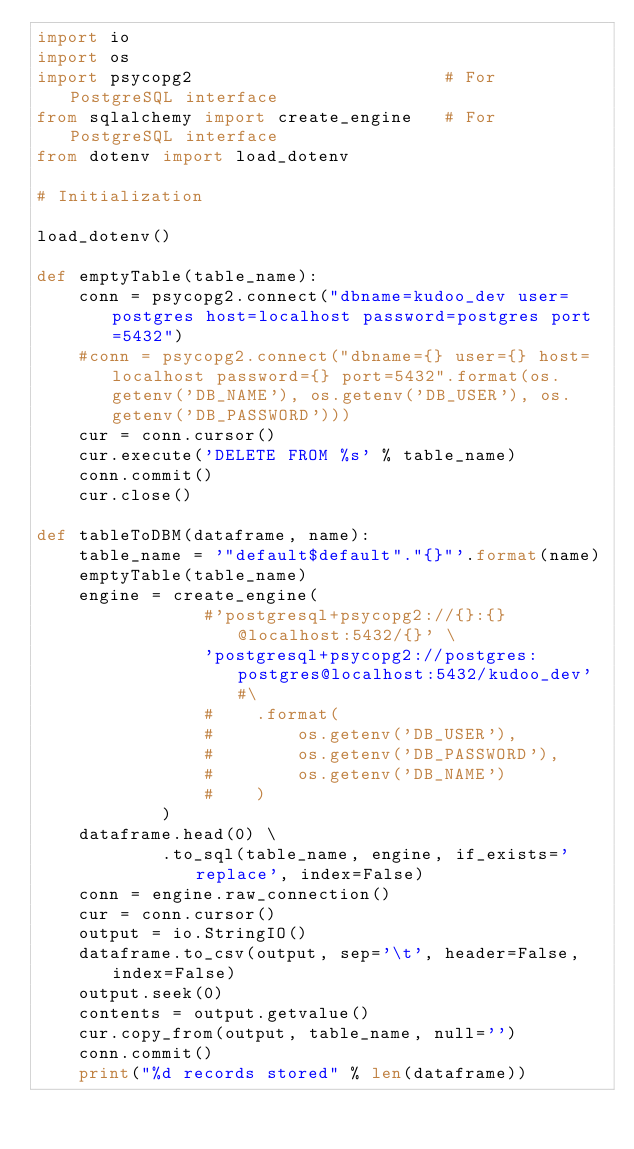Convert code to text. <code><loc_0><loc_0><loc_500><loc_500><_Python_>import io
import os
import psycopg2                        # For PostgreSQL interface
from sqlalchemy import create_engine   # For PostgreSQL interface
from dotenv import load_dotenv

# Initialization

load_dotenv()

def emptyTable(table_name):
    conn = psycopg2.connect("dbname=kudoo_dev user=postgres host=localhost password=postgres port=5432")
    #conn = psycopg2.connect("dbname={} user={} host=localhost password={} port=5432".format(os.getenv('DB_NAME'), os.getenv('DB_USER'), os.getenv('DB_PASSWORD')))
    cur = conn.cursor()
    cur.execute('DELETE FROM %s' % table_name)
    conn.commit()
    cur.close()

def tableToDBM(dataframe, name):
    table_name = '"default$default"."{}"'.format(name)
    emptyTable(table_name)
    engine = create_engine(
                #'postgresql+psycopg2://{}:{}@localhost:5432/{}' \
                'postgresql+psycopg2://postgres:postgres@localhost:5432/kudoo_dev' #\
                #    .format(
                #        os.getenv('DB_USER'),
                #        os.getenv('DB_PASSWORD'),
                #        os.getenv('DB_NAME')
                #    )
            )
    dataframe.head(0) \
            .to_sql(table_name, engine, if_exists='replace', index=False)
    conn = engine.raw_connection()
    cur = conn.cursor()
    output = io.StringIO()
    dataframe.to_csv(output, sep='\t', header=False, index=False)
    output.seek(0)
    contents = output.getvalue()
    cur.copy_from(output, table_name, null='')
    conn.commit()
    print("%d records stored" % len(dataframe))
</code> 